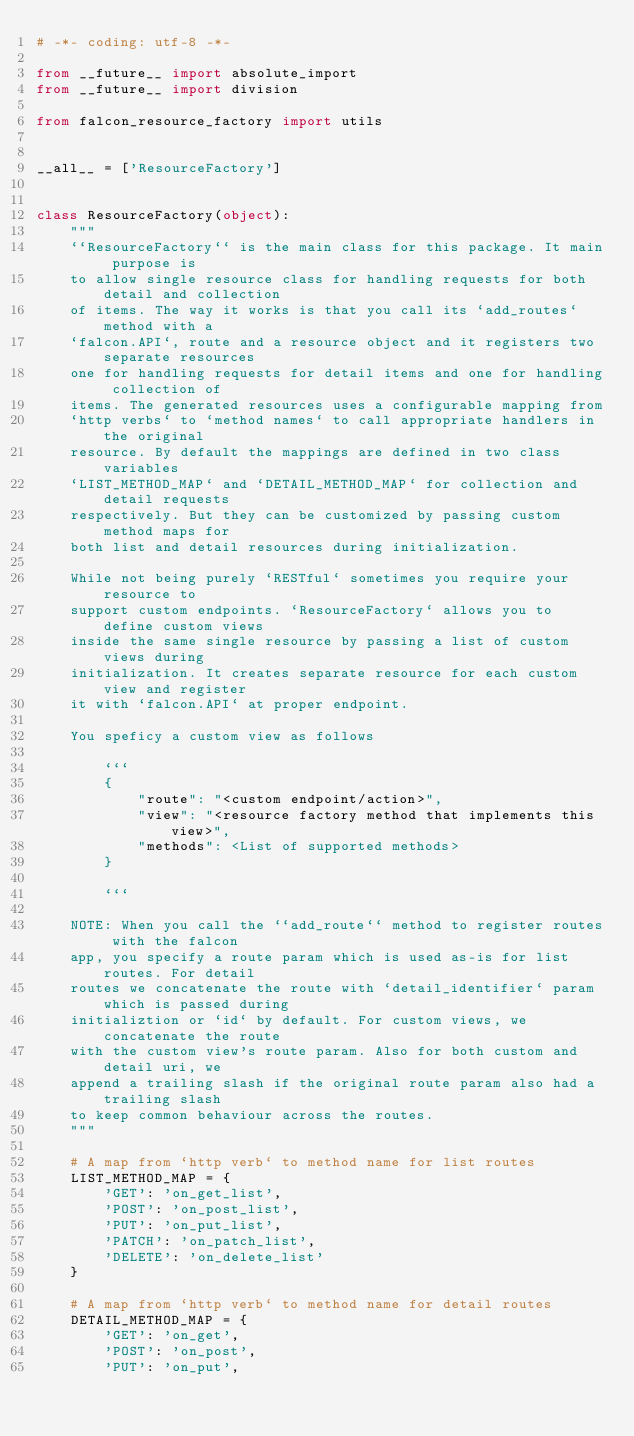<code> <loc_0><loc_0><loc_500><loc_500><_Python_># -*- coding: utf-8 -*-

from __future__ import absolute_import
from __future__ import division

from falcon_resource_factory import utils


__all__ = ['ResourceFactory']


class ResourceFactory(object):
    """
    ``ResourceFactory`` is the main class for this package. It main purpose is
    to allow single resource class for handling requests for both detail and collection
    of items. The way it works is that you call its `add_routes` method with a
    `falcon.API`, route and a resource object and it registers two separate resources
    one for handling requests for detail items and one for handling collection of
    items. The generated resources uses a configurable mapping from
    `http verbs` to `method names` to call appropriate handlers in the original
    resource. By default the mappings are defined in two class variables
    `LIST_METHOD_MAP` and `DETAIL_METHOD_MAP` for collection and detail requests
    respectively. But they can be customized by passing custom method maps for
    both list and detail resources during initialization.

    While not being purely `RESTful` sometimes you require your resource to
    support custom endpoints. `ResourceFactory` allows you to define custom views
    inside the same single resource by passing a list of custom views during
    initialization. It creates separate resource for each custom view and register
    it with `falcon.API` at proper endpoint.

    You speficy a custom view as follows

        ```
        {
            "route": "<custom endpoint/action>",
            "view": "<resource factory method that implements this view>",
            "methods": <List of supported methods>
        }

        ```

    NOTE: When you call the ``add_route`` method to register routes with the falcon
    app, you specify a route param which is used as-is for list routes. For detail
    routes we concatenate the route with `detail_identifier` param which is passed during
    initializtion or `id` by default. For custom views, we concatenate the route
    with the custom view's route param. Also for both custom and detail uri, we
    append a trailing slash if the original route param also had a trailing slash
    to keep common behaviour across the routes.
    """

    # A map from `http verb` to method name for list routes
    LIST_METHOD_MAP = {
        'GET': 'on_get_list',
        'POST': 'on_post_list',
        'PUT': 'on_put_list',
        'PATCH': 'on_patch_list',
        'DELETE': 'on_delete_list'
    }

    # A map from `http verb` to method name for detail routes
    DETAIL_METHOD_MAP = {
        'GET': 'on_get',
        'POST': 'on_post',
        'PUT': 'on_put',</code> 